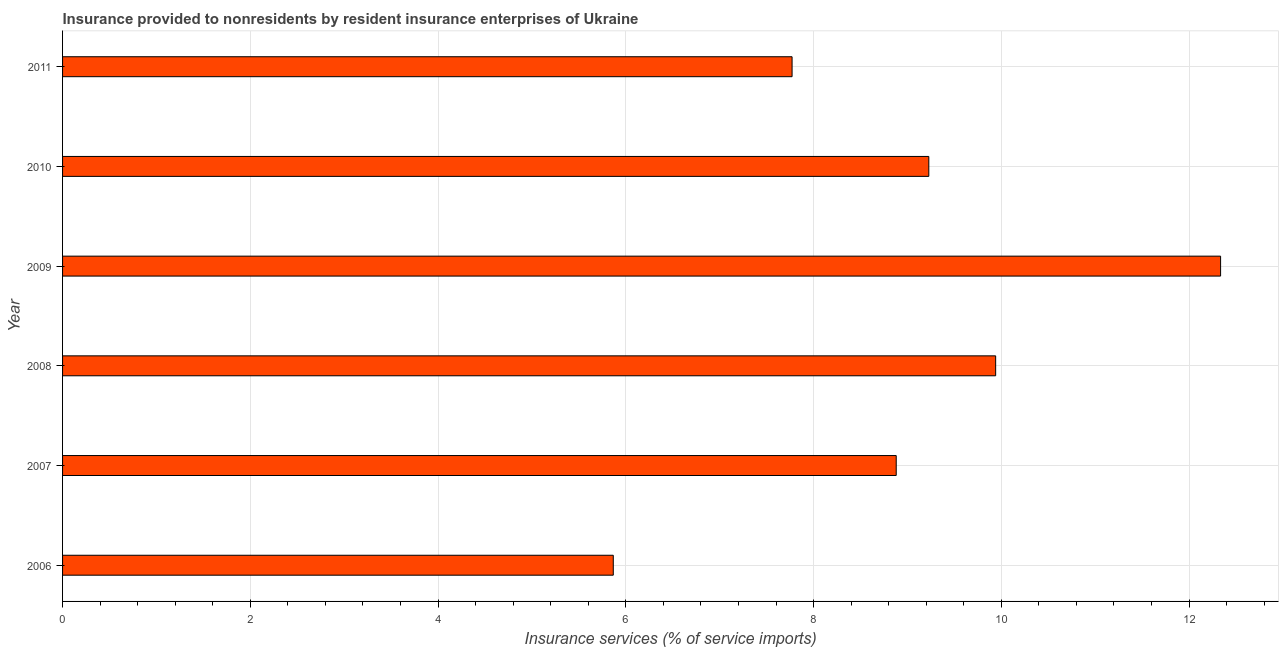Does the graph contain any zero values?
Your response must be concise. No. Does the graph contain grids?
Offer a terse response. Yes. What is the title of the graph?
Offer a very short reply. Insurance provided to nonresidents by resident insurance enterprises of Ukraine. What is the label or title of the X-axis?
Give a very brief answer. Insurance services (% of service imports). What is the insurance and financial services in 2010?
Provide a succinct answer. 9.23. Across all years, what is the maximum insurance and financial services?
Offer a terse response. 12.34. Across all years, what is the minimum insurance and financial services?
Your answer should be very brief. 5.87. In which year was the insurance and financial services maximum?
Provide a short and direct response. 2009. What is the sum of the insurance and financial services?
Ensure brevity in your answer.  54.02. What is the difference between the insurance and financial services in 2009 and 2010?
Your response must be concise. 3.11. What is the average insurance and financial services per year?
Ensure brevity in your answer.  9. What is the median insurance and financial services?
Make the answer very short. 9.05. What is the ratio of the insurance and financial services in 2009 to that in 2011?
Offer a terse response. 1.59. Is the insurance and financial services in 2007 less than that in 2011?
Offer a terse response. No. What is the difference between the highest and the second highest insurance and financial services?
Your answer should be compact. 2.4. Is the sum of the insurance and financial services in 2006 and 2011 greater than the maximum insurance and financial services across all years?
Provide a succinct answer. Yes. What is the difference between the highest and the lowest insurance and financial services?
Your answer should be very brief. 6.47. In how many years, is the insurance and financial services greater than the average insurance and financial services taken over all years?
Make the answer very short. 3. Are all the bars in the graph horizontal?
Offer a very short reply. Yes. How many years are there in the graph?
Ensure brevity in your answer.  6. What is the Insurance services (% of service imports) of 2006?
Provide a short and direct response. 5.87. What is the Insurance services (% of service imports) of 2007?
Your answer should be compact. 8.88. What is the Insurance services (% of service imports) of 2008?
Provide a succinct answer. 9.94. What is the Insurance services (% of service imports) of 2009?
Ensure brevity in your answer.  12.34. What is the Insurance services (% of service imports) of 2010?
Give a very brief answer. 9.23. What is the Insurance services (% of service imports) of 2011?
Give a very brief answer. 7.77. What is the difference between the Insurance services (% of service imports) in 2006 and 2007?
Provide a short and direct response. -3.01. What is the difference between the Insurance services (% of service imports) in 2006 and 2008?
Your answer should be compact. -4.07. What is the difference between the Insurance services (% of service imports) in 2006 and 2009?
Provide a succinct answer. -6.47. What is the difference between the Insurance services (% of service imports) in 2006 and 2010?
Your answer should be compact. -3.36. What is the difference between the Insurance services (% of service imports) in 2006 and 2011?
Offer a very short reply. -1.9. What is the difference between the Insurance services (% of service imports) in 2007 and 2008?
Give a very brief answer. -1.06. What is the difference between the Insurance services (% of service imports) in 2007 and 2009?
Give a very brief answer. -3.46. What is the difference between the Insurance services (% of service imports) in 2007 and 2010?
Provide a short and direct response. -0.35. What is the difference between the Insurance services (% of service imports) in 2007 and 2011?
Provide a succinct answer. 1.11. What is the difference between the Insurance services (% of service imports) in 2008 and 2009?
Your answer should be very brief. -2.4. What is the difference between the Insurance services (% of service imports) in 2008 and 2010?
Your response must be concise. 0.71. What is the difference between the Insurance services (% of service imports) in 2008 and 2011?
Keep it short and to the point. 2.17. What is the difference between the Insurance services (% of service imports) in 2009 and 2010?
Keep it short and to the point. 3.11. What is the difference between the Insurance services (% of service imports) in 2009 and 2011?
Keep it short and to the point. 4.56. What is the difference between the Insurance services (% of service imports) in 2010 and 2011?
Your answer should be compact. 1.46. What is the ratio of the Insurance services (% of service imports) in 2006 to that in 2007?
Give a very brief answer. 0.66. What is the ratio of the Insurance services (% of service imports) in 2006 to that in 2008?
Offer a terse response. 0.59. What is the ratio of the Insurance services (% of service imports) in 2006 to that in 2009?
Your answer should be compact. 0.48. What is the ratio of the Insurance services (% of service imports) in 2006 to that in 2010?
Ensure brevity in your answer.  0.64. What is the ratio of the Insurance services (% of service imports) in 2006 to that in 2011?
Provide a short and direct response. 0.76. What is the ratio of the Insurance services (% of service imports) in 2007 to that in 2008?
Ensure brevity in your answer.  0.89. What is the ratio of the Insurance services (% of service imports) in 2007 to that in 2009?
Your response must be concise. 0.72. What is the ratio of the Insurance services (% of service imports) in 2007 to that in 2011?
Your answer should be very brief. 1.14. What is the ratio of the Insurance services (% of service imports) in 2008 to that in 2009?
Provide a short and direct response. 0.81. What is the ratio of the Insurance services (% of service imports) in 2008 to that in 2010?
Ensure brevity in your answer.  1.08. What is the ratio of the Insurance services (% of service imports) in 2008 to that in 2011?
Offer a terse response. 1.28. What is the ratio of the Insurance services (% of service imports) in 2009 to that in 2010?
Your answer should be very brief. 1.34. What is the ratio of the Insurance services (% of service imports) in 2009 to that in 2011?
Offer a very short reply. 1.59. What is the ratio of the Insurance services (% of service imports) in 2010 to that in 2011?
Your response must be concise. 1.19. 